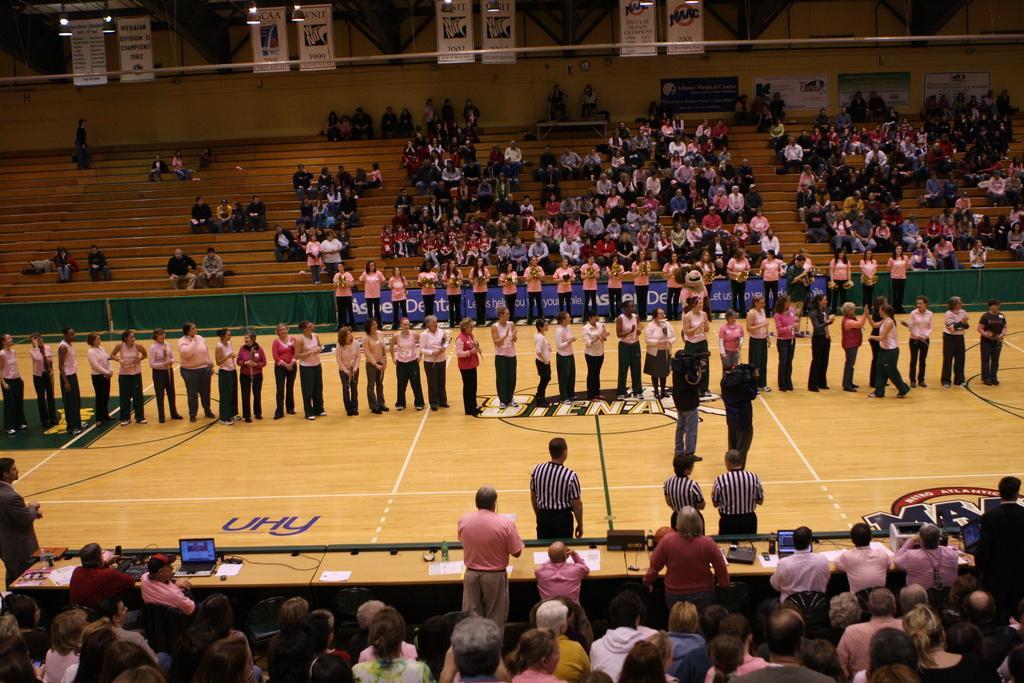Describe this image in one or two sentences. In this picture I can see few people are standing and few are sitting and I can see couple of laptops, papers, bottles on the tables and I can see couple of men holding cameras in their hands and I can see banners with some text and few lights on the ceiling and I can see an advertisement board with some text. 